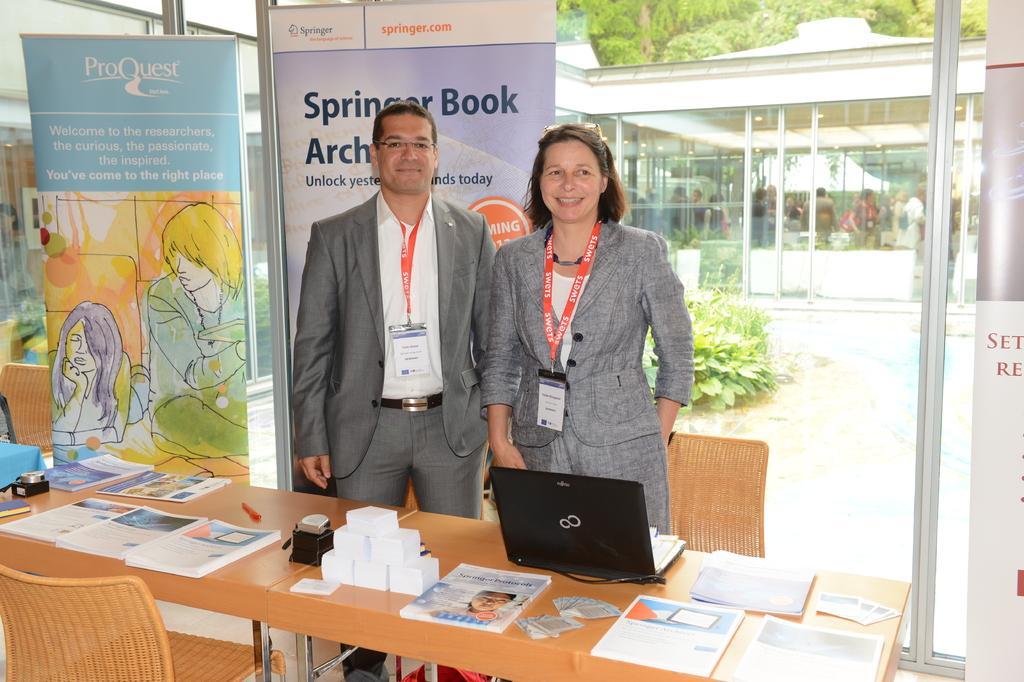In one or two sentences, can you explain what this image depicts? In this image we can see a man and woman is standing near the table by wearing blazers and identity card. There are laptop, papers, pen, books on the top of the table. In the background we can see banners, trees, shrubs, building through the glass window. 